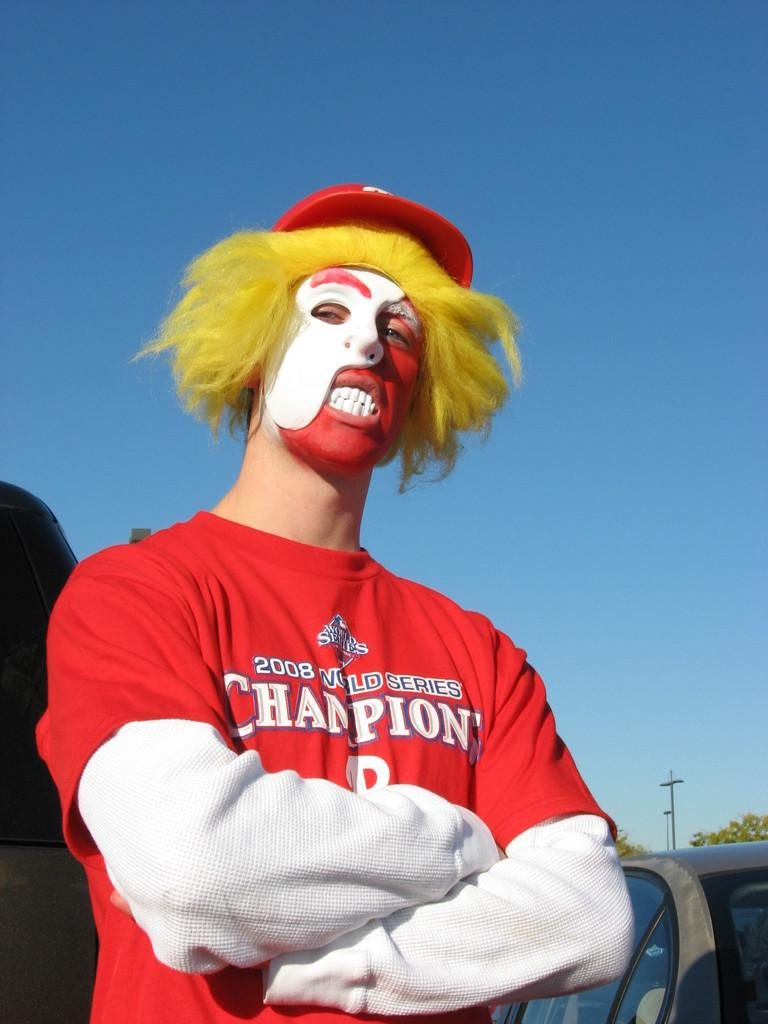<image>
Render a clear and concise summary of the photo. A man with his face painted red and white wearing a yellow wig wears a Champions t-shirt. 